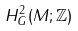<formula> <loc_0><loc_0><loc_500><loc_500>H _ { G } ^ { 2 } ( M ; \mathbb { Z } )</formula> 